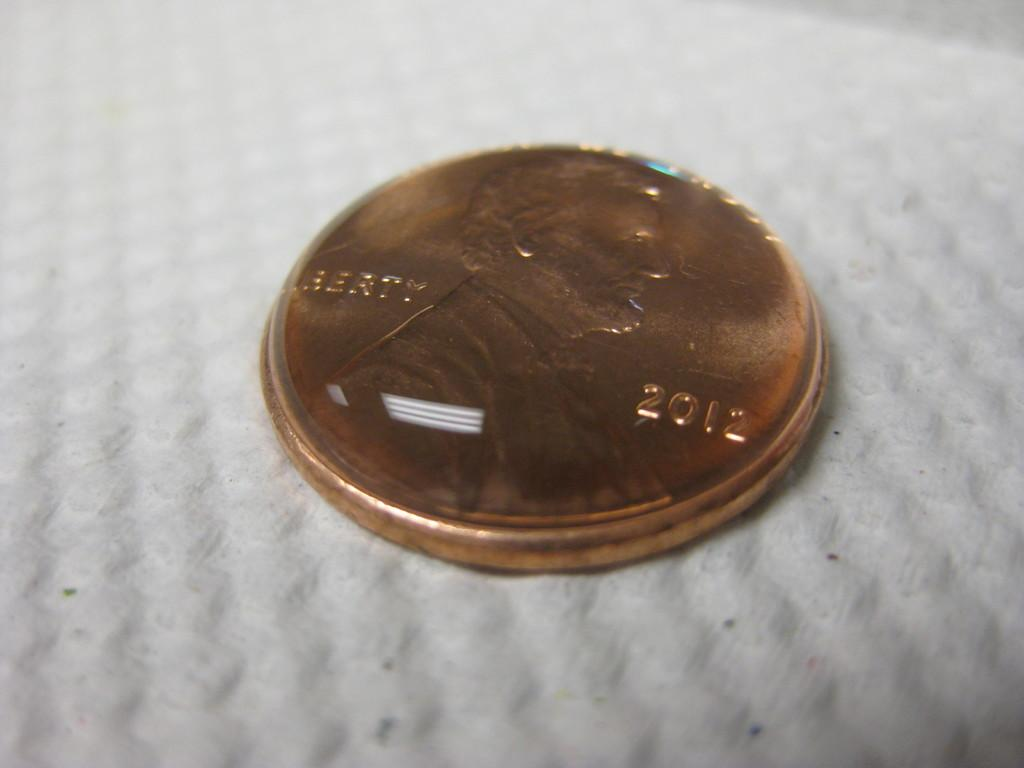<image>
Create a compact narrative representing the image presented. A 2012 copper penny is laying on head. 